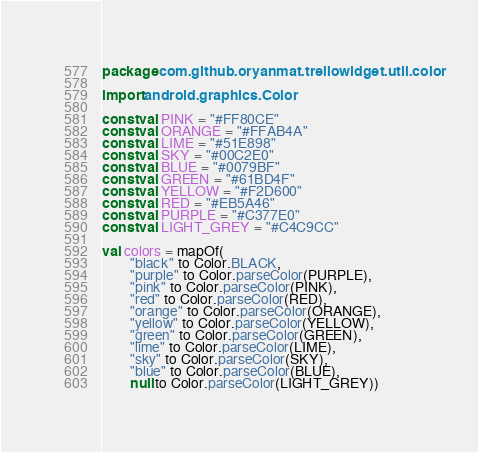Convert code to text. <code><loc_0><loc_0><loc_500><loc_500><_Kotlin_>package com.github.oryanmat.trellowidget.util.color

import android.graphics.Color

const val PINK = "#FF80CE"
const val ORANGE = "#FFAB4A"
const val LIME = "#51E898"
const val SKY = "#00C2E0"
const val BLUE = "#0079BF"
const val GREEN = "#61BD4F"
const val YELLOW = "#F2D600"
const val RED = "#EB5A46"
const val PURPLE = "#C377E0"
const val LIGHT_GREY = "#C4C9CC"

val colors = mapOf(
        "black" to Color.BLACK,
        "purple" to Color.parseColor(PURPLE),
        "pink" to Color.parseColor(PINK),
        "red" to Color.parseColor(RED),
        "orange" to Color.parseColor(ORANGE),
        "yellow" to Color.parseColor(YELLOW),
        "green" to Color.parseColor(GREEN),
        "lime" to Color.parseColor(LIME),
        "sky" to Color.parseColor(SKY),
        "blue" to Color.parseColor(BLUE),
        null to Color.parseColor(LIGHT_GREY))</code> 